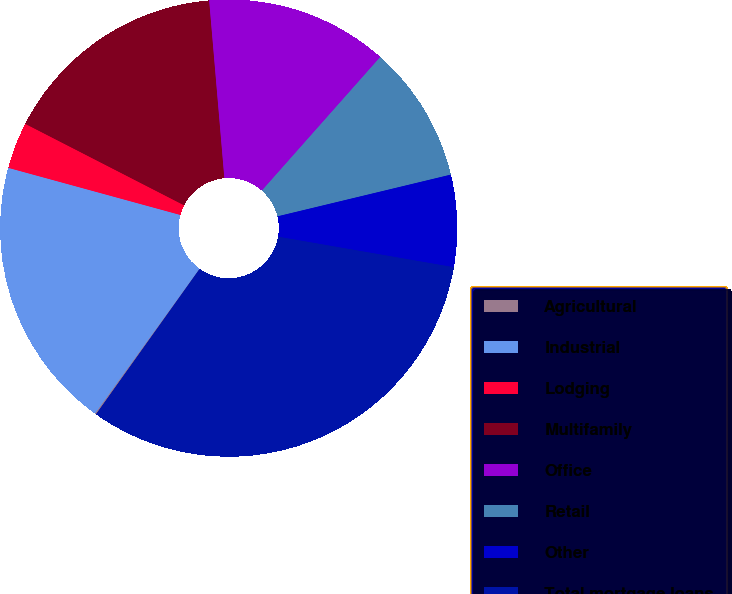Convert chart to OTSL. <chart><loc_0><loc_0><loc_500><loc_500><pie_chart><fcel>Agricultural<fcel>Industrial<fcel>Lodging<fcel>Multifamily<fcel>Office<fcel>Retail<fcel>Other<fcel>Total mortgage loans<nl><fcel>0.09%<fcel>19.31%<fcel>3.29%<fcel>16.1%<fcel>12.9%<fcel>9.7%<fcel>6.5%<fcel>32.12%<nl></chart> 